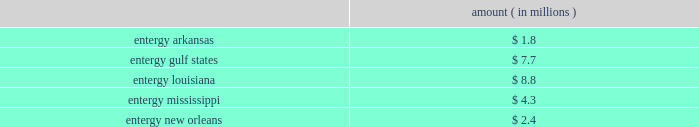Domestic utility companies and system energy notes to respective financial statements protested the disallowance of these deductions to the office of irs appeals .
Entergy expects to receive a notice of deficiency in 2005 for this item , and plans to vigorously contest this matter .
Entergy believes that the contingency provision established in its financial statements sufficiently covers the risk associated with this item .
Mark to market of certain power contracts in 2001 , entergy louisiana changed its method of accounting for tax purposes related to its wholesale electric power contracts .
The most significant of these is the contract to purchase power from the vidalia hydroelectric project .
The new tax accounting method has provided a cumulative cash flow benefit of approximately $ 790 million as of december 31 , 2004 .
The related irs interest exposure is $ 93 million at december 31 , 2004 .
This benefit is expected to reverse in the years 2005 through 2031 .
The election did not reduce book income tax expense .
The timing of the reversal of this benefit depends on several variables , including the price of power .
Due to the temporary nature of the tax benefit , the potential interest charge represents entergy's net earnings exposure .
Entergy louisiana's 2001 tax return is currently under examination by the irs , though no adjustments have yet been proposed with respect to the mark to market election .
Entergy believes that the contingency provision established in its financial statements will sufficiently cover the risk associated with this issue .
Cashpoint bankruptcy ( entergy arkansas , entergy gulf states , entergy louisiana , entergy mississippi , and entergy new orleans ) in 2003 the domestic utility companies entered an agreement with cashpoint network services ( cashpoint ) under which cashpoint was to manage a network of payment agents through which entergy's utility customers could pay their bills .
The payment agent system allows customers to pay their bills at various commercial or governmental locations , rather than sending payments by mail .
Approximately one-third of entergy's utility customers use payment agents .
On april 19 , 2004 , cashpoint failed to pay funds due to the domestic utility companies that had been collected through payment agents .
The domestic utility companies then obtained a temporary restraining order from the civil district court for the parish of orleans , state of louisiana , enjoining cashpoint from distributing funds belonging to entergy , except by paying those funds to entergy .
On april 22 , 2004 , a petition for involuntary chapter 7 bankruptcy was filed against cashpoint by other creditors in the united states bankruptcy court for the southern district of new york .
In response to these events , the domestic utility companies expanded an existing contract with another company to manage all of their payment agents .
The domestic utility companies filed proofs of claim in the cashpoint bankruptcy proceeding in september 2004 .
Although entergy cannot precisely determine at this time the amount that cashpoint owes to the domestic utility companies that may not be repaid , it has accrued an estimate of loss based on current information .
If no cash is repaid to the domestic utility companies , an event entergy does not believe is likely , the current estimates of maximum exposure to loss are approximately as follows : amount ( in millions ) .
Environmental issues ( entergy gulf states ) entergy gulf states has been designated as a prp for the cleanup of certain hazardous waste disposal sites .
As of december 31 , 2004 , entergy gulf states does not expect the remaining clean-up costs to exceed its recorded liability of $ 1.5 million for the remaining sites at which the epa has designated entergy gulf states as a prp. .
What are the current estimates of maximum exposure to loss for entergy louisiana as a percentage of the cumulative cash flow benefit? 
Computations: (8.8 / 790)
Answer: 0.01114. 